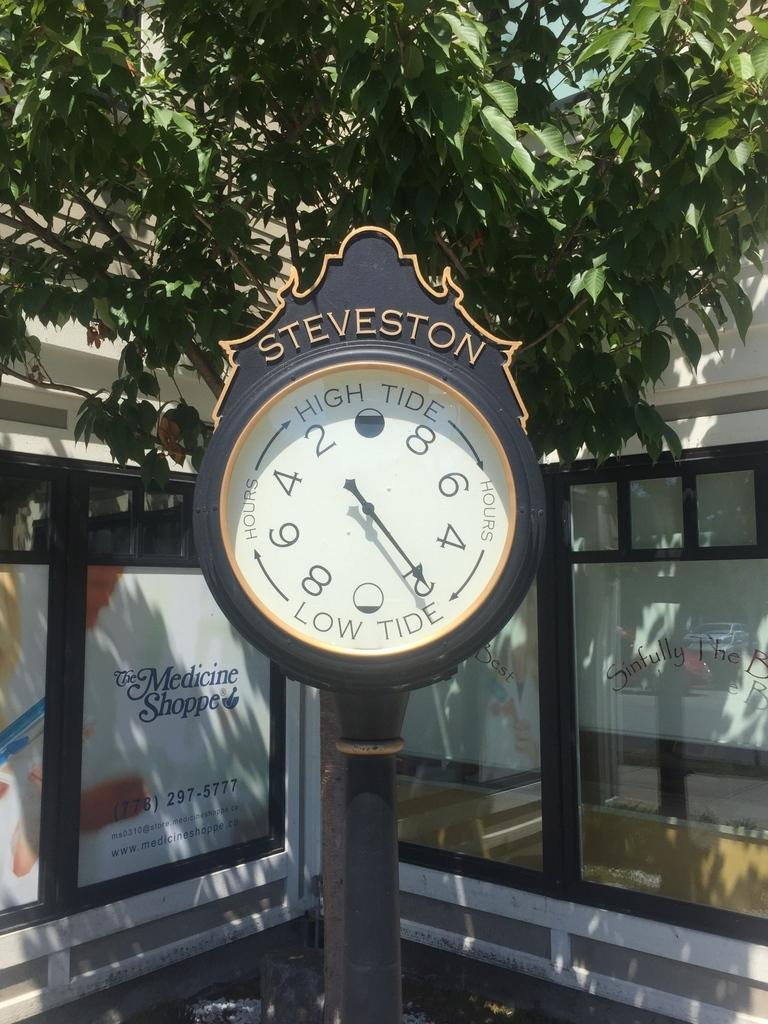What is the main object with text in the image? There is a measuring meter with text in the image. What type of structure is present in the image? There is a house in the image. What feature can be seen on the house? The house has windows. What is displayed on the windows of the house? There are posters with text on the windows. What type of vegetation is visible in the image? There is a tree visible in the image. What type of linen is draped over the tree in the image? There is no linen draped over the tree in the image. What type of drink is being served in the house in the image? The image does not show any drinks being served inside the house. 